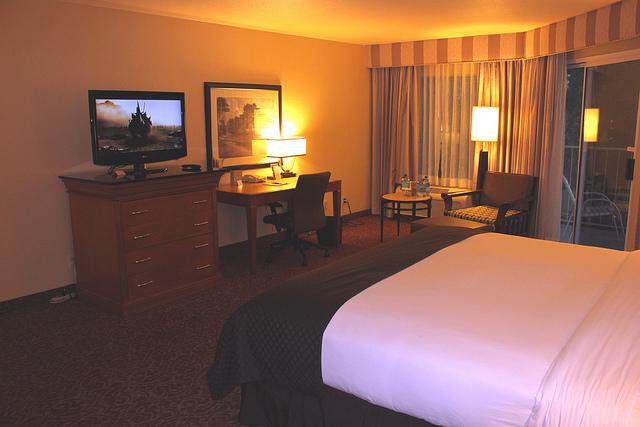What is on the TV?
Write a very short answer. Ship. What is hanging above the desk?
Answer briefly. Picture. How many lamps is there?
Give a very brief answer. 2. Are there any photos on the wall?
Be succinct. Yes. Is this a home?
Give a very brief answer. No. 